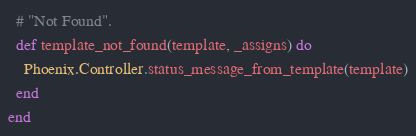Convert code to text. <code><loc_0><loc_0><loc_500><loc_500><_Elixir_>  # "Not Found".
  def template_not_found(template, _assigns) do
    Phoenix.Controller.status_message_from_template(template)
  end
end
</code> 